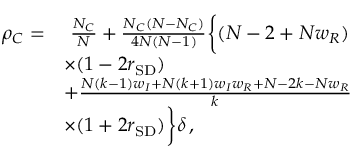<formula> <loc_0><loc_0><loc_500><loc_500>\begin{array} { r l } { \rho _ { C } = } & { \frac { N _ { C } } { N } + \frac { N _ { C } ( N - N _ { C } ) } { 4 N ( N - 1 ) } \left \{ ( N - 2 + N w _ { R } ) } \\ & { \times ( 1 - 2 r _ { S D } ) } \\ & { + \frac { N ( k - 1 ) w _ { I } + N ( k + 1 ) w _ { I } w _ { R } + N - 2 k - N w _ { R } } { k } } \\ & { \times ( 1 + 2 r _ { S D } ) \right \} \delta \, , } \end{array}</formula> 